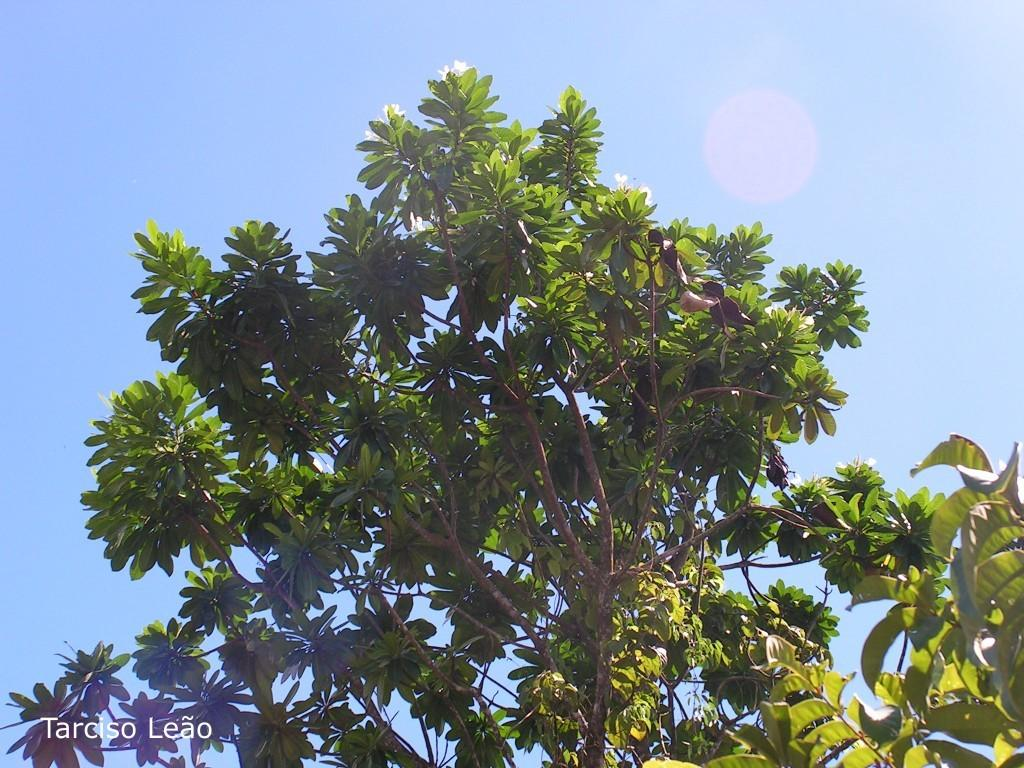What type of vegetation can be seen on the trees in the image? There are flowers on the trees in the image. What type of potato is being watered by the hose in the image? There is no hose or potato present in the image; it only features flowers on the trees. 